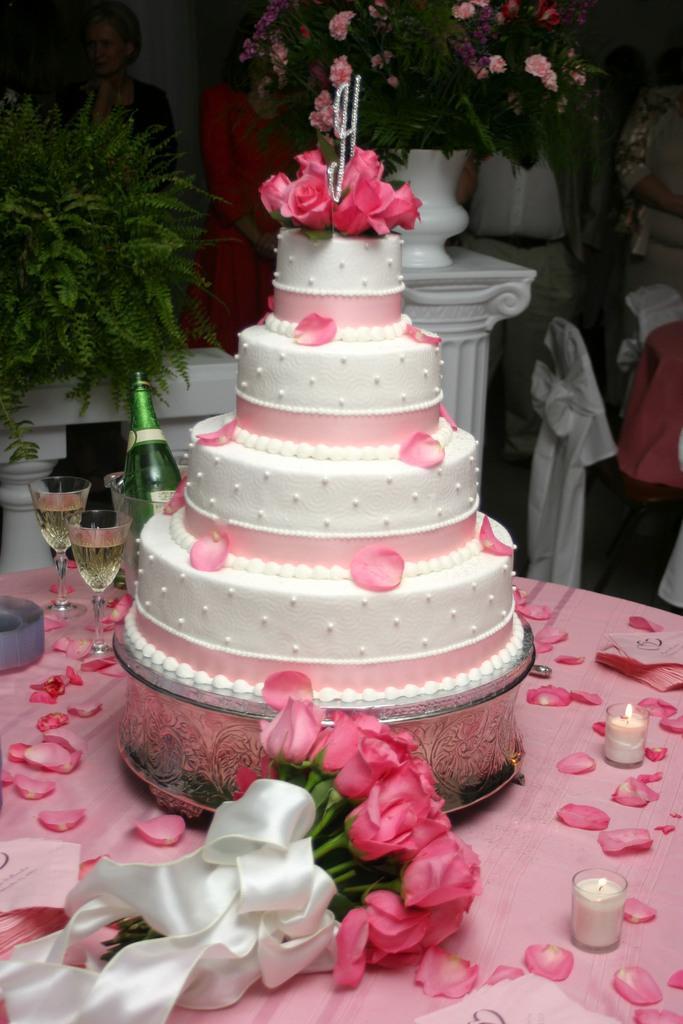Describe this image in one or two sentences. There is a four layer white and pink cake. There are rose petals on it. There is a rose bouquet, glasses of drink and a glass bottle. At the back there are flowers. 